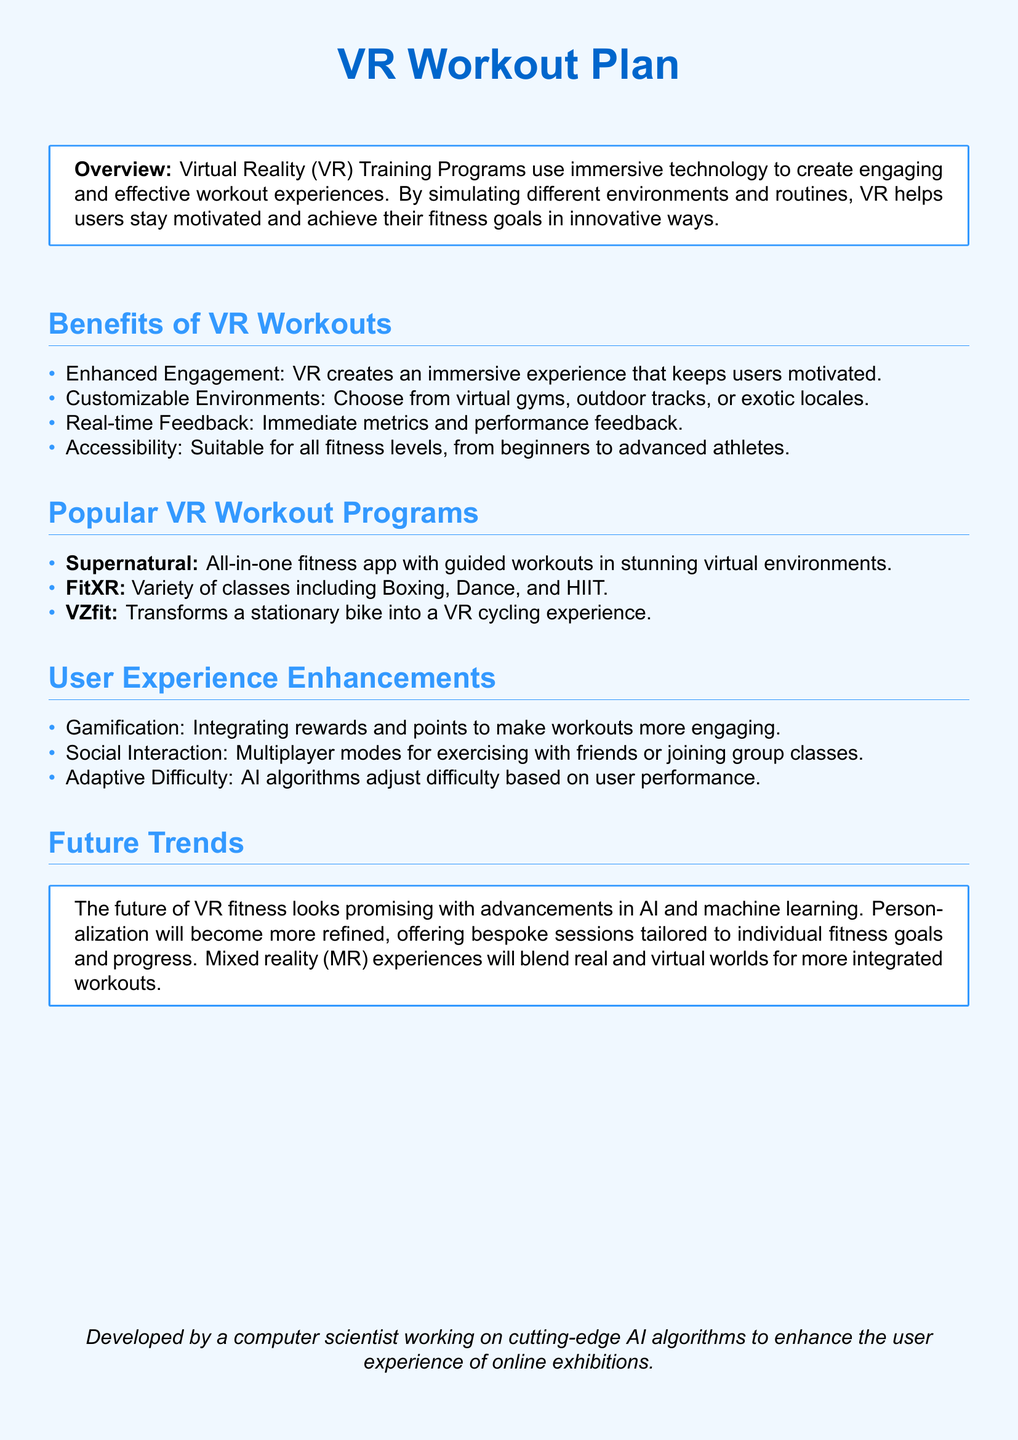What is the title of the document? The title is prominently displayed at the top of the document, indicating the main focus of the content.
Answer: VR Workout Plan What is one benefit of VR workouts? The document lists several benefits of VR workouts under their respective section, which highlight the advantages of this training method.
Answer: Enhanced Engagement Name one popular VR workout program mentioned. The document provides a list of popular VR workout programs as examples of available options for users.
Answer: Supernatural What type of interaction does FitXR offer? The information within the document highlights different classes available in FitXR, specifying what kind of workouts the program includes.
Answer: Boxing How does the system provide feedback? The overview of VR benefits explains that users receive performance metrics immediately during their workouts.
Answer: Real-time Feedback What technology is expected to enhance the future of VR fitness? The document outlines trends and advancements that could influence VR fitness, focusing on specific technological developments.
Answer: AI and machine learning How do VR workouts cater to different fitness levels? The benefits section discusses the accessibility feature of VR workouts, making it identifiable to various user groups.
Answer: Suitable for all fitness levels What gaming element is included in user experience enhancements? The section on user experience improvements mentions a particular approach that involves game-like features to maintain user engagement.
Answer: Gamification What is the role of AI in adaptive difficulty? The document explains how AI algorithms contribute to personalizing the workout experience specifically by modifying challenge levels based on user input.
Answer: Adjust difficulty based on user performance 